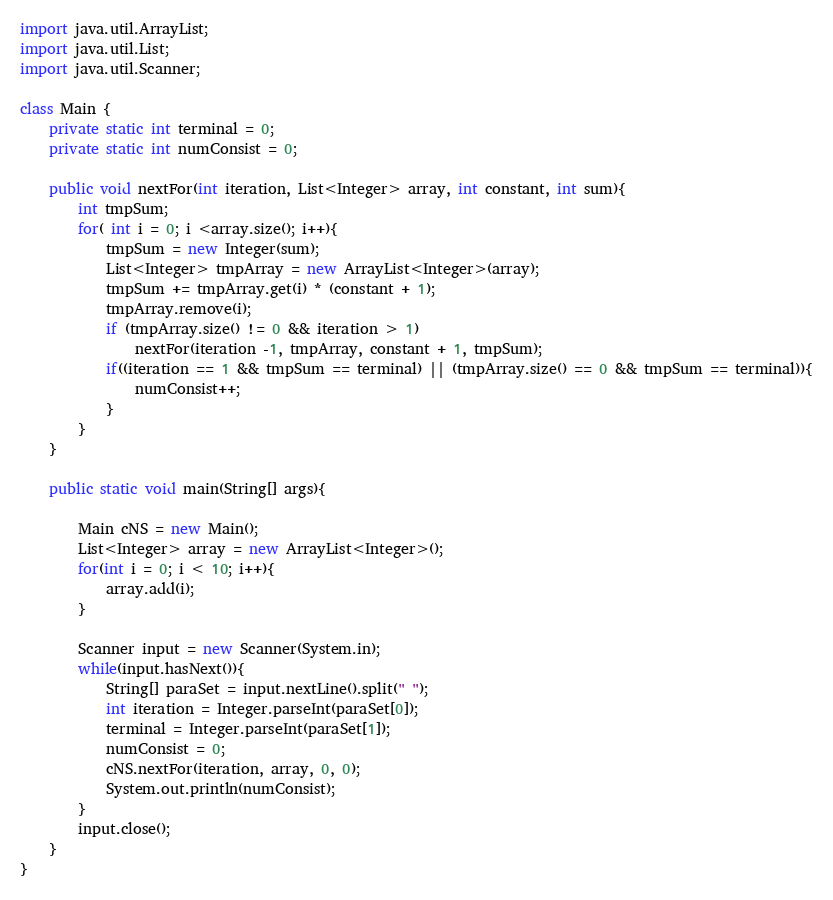Convert code to text. <code><loc_0><loc_0><loc_500><loc_500><_Java_>import java.util.ArrayList;
import java.util.List;
import java.util.Scanner;

class Main {
	private static int terminal = 0;
	private static int numConsist = 0;

	public void nextFor(int iteration, List<Integer> array, int constant, int sum){
		int tmpSum;
		for( int i = 0; i <array.size(); i++){
			tmpSum = new Integer(sum);
			List<Integer> tmpArray = new ArrayList<Integer>(array);
			tmpSum += tmpArray.get(i) * (constant + 1);
			tmpArray.remove(i);
			if (tmpArray.size() != 0 && iteration > 1)
				nextFor(iteration -1, tmpArray, constant + 1, tmpSum);
			if((iteration == 1 && tmpSum == terminal) || (tmpArray.size() == 0 && tmpSum == terminal)){
				numConsist++;
			}
		}
	}

	public static void main(String[] args){

		Main cNS = new Main();
		List<Integer> array = new ArrayList<Integer>();
		for(int i = 0; i < 10; i++){
			array.add(i);
		}

		Scanner input = new Scanner(System.in);
		while(input.hasNext()){
			String[] paraSet = input.nextLine().split(" ");
			int iteration = Integer.parseInt(paraSet[0]);
			terminal = Integer.parseInt(paraSet[1]);
            numConsist = 0;
			cNS.nextFor(iteration, array, 0, 0);
			System.out.println(numConsist);
		}
		input.close();
	}
}</code> 